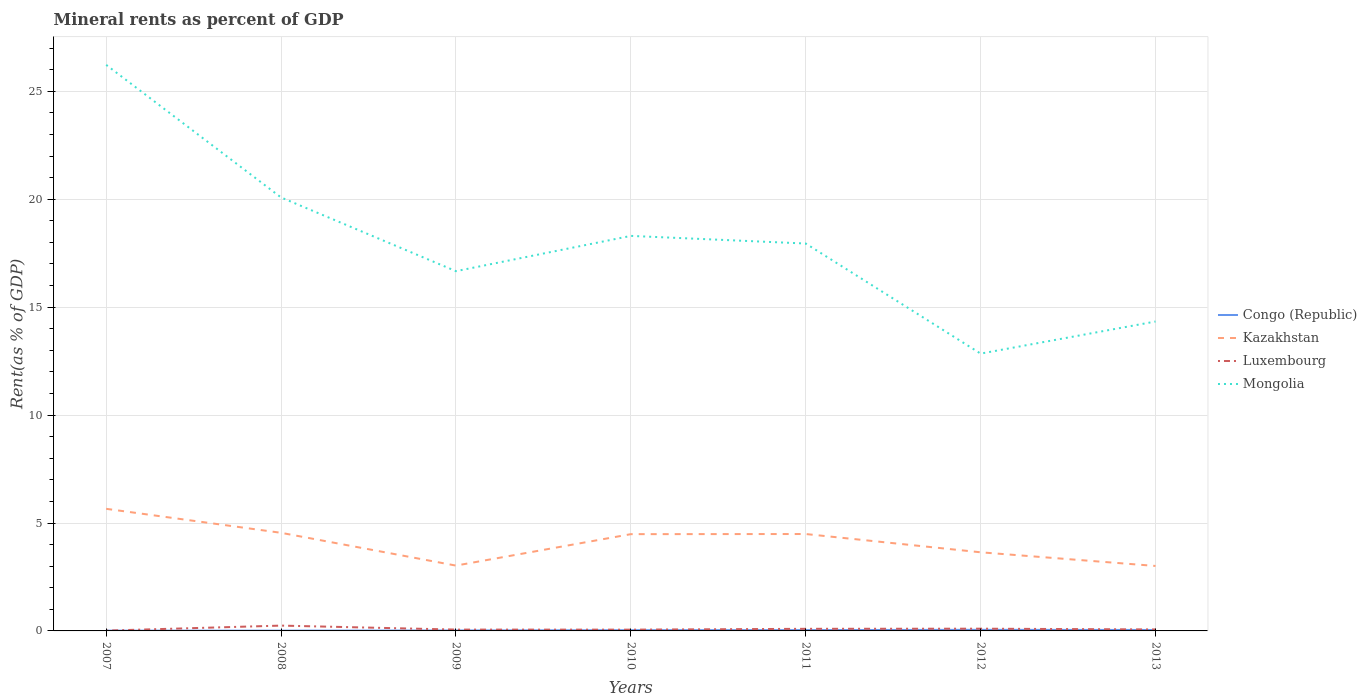How many different coloured lines are there?
Your answer should be very brief. 4. Does the line corresponding to Congo (Republic) intersect with the line corresponding to Kazakhstan?
Your response must be concise. No. Is the number of lines equal to the number of legend labels?
Offer a terse response. Yes. Across all years, what is the maximum mineral rent in Luxembourg?
Offer a very short reply. 0.01. In which year was the mineral rent in Luxembourg maximum?
Your response must be concise. 2007. What is the total mineral rent in Mongolia in the graph?
Your answer should be compact. 5.75. What is the difference between the highest and the second highest mineral rent in Congo (Republic)?
Provide a short and direct response. 0.04. Is the mineral rent in Luxembourg strictly greater than the mineral rent in Mongolia over the years?
Ensure brevity in your answer.  Yes. How many years are there in the graph?
Ensure brevity in your answer.  7. Does the graph contain any zero values?
Ensure brevity in your answer.  No. Where does the legend appear in the graph?
Keep it short and to the point. Center right. What is the title of the graph?
Make the answer very short. Mineral rents as percent of GDP. Does "New Zealand" appear as one of the legend labels in the graph?
Offer a very short reply. No. What is the label or title of the X-axis?
Offer a very short reply. Years. What is the label or title of the Y-axis?
Ensure brevity in your answer.  Rent(as % of GDP). What is the Rent(as % of GDP) in Congo (Republic) in 2007?
Your response must be concise. 0.01. What is the Rent(as % of GDP) in Kazakhstan in 2007?
Provide a short and direct response. 5.66. What is the Rent(as % of GDP) of Luxembourg in 2007?
Give a very brief answer. 0.01. What is the Rent(as % of GDP) of Mongolia in 2007?
Provide a short and direct response. 26.23. What is the Rent(as % of GDP) of Congo (Republic) in 2008?
Make the answer very short. 0.01. What is the Rent(as % of GDP) in Kazakhstan in 2008?
Your answer should be compact. 4.55. What is the Rent(as % of GDP) of Luxembourg in 2008?
Give a very brief answer. 0.25. What is the Rent(as % of GDP) of Mongolia in 2008?
Offer a very short reply. 20.08. What is the Rent(as % of GDP) in Congo (Republic) in 2009?
Make the answer very short. 0.02. What is the Rent(as % of GDP) in Kazakhstan in 2009?
Give a very brief answer. 3.03. What is the Rent(as % of GDP) of Luxembourg in 2009?
Your answer should be compact. 0.06. What is the Rent(as % of GDP) in Mongolia in 2009?
Your response must be concise. 16.67. What is the Rent(as % of GDP) in Congo (Republic) in 2010?
Offer a terse response. 0.03. What is the Rent(as % of GDP) of Kazakhstan in 2010?
Provide a succinct answer. 4.48. What is the Rent(as % of GDP) in Luxembourg in 2010?
Keep it short and to the point. 0.06. What is the Rent(as % of GDP) in Mongolia in 2010?
Make the answer very short. 18.3. What is the Rent(as % of GDP) in Congo (Republic) in 2011?
Ensure brevity in your answer.  0.04. What is the Rent(as % of GDP) in Kazakhstan in 2011?
Offer a very short reply. 4.49. What is the Rent(as % of GDP) of Luxembourg in 2011?
Your answer should be compact. 0.1. What is the Rent(as % of GDP) in Mongolia in 2011?
Your answer should be compact. 17.95. What is the Rent(as % of GDP) in Congo (Republic) in 2012?
Provide a short and direct response. 0.05. What is the Rent(as % of GDP) in Kazakhstan in 2012?
Offer a terse response. 3.64. What is the Rent(as % of GDP) in Luxembourg in 2012?
Provide a short and direct response. 0.1. What is the Rent(as % of GDP) in Mongolia in 2012?
Give a very brief answer. 12.85. What is the Rent(as % of GDP) of Congo (Republic) in 2013?
Make the answer very short. 0.04. What is the Rent(as % of GDP) of Kazakhstan in 2013?
Keep it short and to the point. 3.01. What is the Rent(as % of GDP) of Luxembourg in 2013?
Offer a very short reply. 0.07. What is the Rent(as % of GDP) in Mongolia in 2013?
Make the answer very short. 14.34. Across all years, what is the maximum Rent(as % of GDP) in Congo (Republic)?
Ensure brevity in your answer.  0.05. Across all years, what is the maximum Rent(as % of GDP) of Kazakhstan?
Your answer should be very brief. 5.66. Across all years, what is the maximum Rent(as % of GDP) in Luxembourg?
Keep it short and to the point. 0.25. Across all years, what is the maximum Rent(as % of GDP) of Mongolia?
Your answer should be compact. 26.23. Across all years, what is the minimum Rent(as % of GDP) of Congo (Republic)?
Your response must be concise. 0.01. Across all years, what is the minimum Rent(as % of GDP) in Kazakhstan?
Make the answer very short. 3.01. Across all years, what is the minimum Rent(as % of GDP) of Luxembourg?
Provide a short and direct response. 0.01. Across all years, what is the minimum Rent(as % of GDP) of Mongolia?
Provide a succinct answer. 12.85. What is the total Rent(as % of GDP) of Congo (Republic) in the graph?
Give a very brief answer. 0.21. What is the total Rent(as % of GDP) of Kazakhstan in the graph?
Give a very brief answer. 28.85. What is the total Rent(as % of GDP) in Luxembourg in the graph?
Your response must be concise. 0.65. What is the total Rent(as % of GDP) in Mongolia in the graph?
Provide a succinct answer. 126.41. What is the difference between the Rent(as % of GDP) in Congo (Republic) in 2007 and that in 2008?
Give a very brief answer. -0. What is the difference between the Rent(as % of GDP) in Kazakhstan in 2007 and that in 2008?
Make the answer very short. 1.11. What is the difference between the Rent(as % of GDP) in Luxembourg in 2007 and that in 2008?
Keep it short and to the point. -0.23. What is the difference between the Rent(as % of GDP) of Mongolia in 2007 and that in 2008?
Your answer should be very brief. 6.14. What is the difference between the Rent(as % of GDP) of Congo (Republic) in 2007 and that in 2009?
Offer a very short reply. -0.01. What is the difference between the Rent(as % of GDP) in Kazakhstan in 2007 and that in 2009?
Keep it short and to the point. 2.63. What is the difference between the Rent(as % of GDP) in Luxembourg in 2007 and that in 2009?
Your answer should be compact. -0.05. What is the difference between the Rent(as % of GDP) in Mongolia in 2007 and that in 2009?
Provide a short and direct response. 9.56. What is the difference between the Rent(as % of GDP) in Congo (Republic) in 2007 and that in 2010?
Offer a terse response. -0.02. What is the difference between the Rent(as % of GDP) in Kazakhstan in 2007 and that in 2010?
Your response must be concise. 1.17. What is the difference between the Rent(as % of GDP) of Luxembourg in 2007 and that in 2010?
Your answer should be compact. -0.04. What is the difference between the Rent(as % of GDP) in Mongolia in 2007 and that in 2010?
Your answer should be compact. 7.92. What is the difference between the Rent(as % of GDP) in Congo (Republic) in 2007 and that in 2011?
Ensure brevity in your answer.  -0.03. What is the difference between the Rent(as % of GDP) of Kazakhstan in 2007 and that in 2011?
Provide a succinct answer. 1.17. What is the difference between the Rent(as % of GDP) in Luxembourg in 2007 and that in 2011?
Offer a very short reply. -0.08. What is the difference between the Rent(as % of GDP) in Mongolia in 2007 and that in 2011?
Keep it short and to the point. 8.28. What is the difference between the Rent(as % of GDP) of Congo (Republic) in 2007 and that in 2012?
Your answer should be very brief. -0.04. What is the difference between the Rent(as % of GDP) in Kazakhstan in 2007 and that in 2012?
Offer a terse response. 2.01. What is the difference between the Rent(as % of GDP) of Luxembourg in 2007 and that in 2012?
Your answer should be compact. -0.09. What is the difference between the Rent(as % of GDP) in Mongolia in 2007 and that in 2012?
Offer a terse response. 13.38. What is the difference between the Rent(as % of GDP) in Congo (Republic) in 2007 and that in 2013?
Provide a succinct answer. -0.03. What is the difference between the Rent(as % of GDP) of Kazakhstan in 2007 and that in 2013?
Provide a short and direct response. 2.65. What is the difference between the Rent(as % of GDP) of Luxembourg in 2007 and that in 2013?
Make the answer very short. -0.05. What is the difference between the Rent(as % of GDP) in Mongolia in 2007 and that in 2013?
Provide a succinct answer. 11.89. What is the difference between the Rent(as % of GDP) of Congo (Republic) in 2008 and that in 2009?
Ensure brevity in your answer.  -0.01. What is the difference between the Rent(as % of GDP) of Kazakhstan in 2008 and that in 2009?
Your answer should be very brief. 1.52. What is the difference between the Rent(as % of GDP) of Luxembourg in 2008 and that in 2009?
Give a very brief answer. 0.18. What is the difference between the Rent(as % of GDP) of Mongolia in 2008 and that in 2009?
Make the answer very short. 3.42. What is the difference between the Rent(as % of GDP) of Congo (Republic) in 2008 and that in 2010?
Your answer should be compact. -0.02. What is the difference between the Rent(as % of GDP) of Kazakhstan in 2008 and that in 2010?
Keep it short and to the point. 0.06. What is the difference between the Rent(as % of GDP) of Luxembourg in 2008 and that in 2010?
Keep it short and to the point. 0.19. What is the difference between the Rent(as % of GDP) in Mongolia in 2008 and that in 2010?
Ensure brevity in your answer.  1.78. What is the difference between the Rent(as % of GDP) of Congo (Republic) in 2008 and that in 2011?
Ensure brevity in your answer.  -0.03. What is the difference between the Rent(as % of GDP) of Kazakhstan in 2008 and that in 2011?
Your answer should be compact. 0.06. What is the difference between the Rent(as % of GDP) in Luxembourg in 2008 and that in 2011?
Keep it short and to the point. 0.15. What is the difference between the Rent(as % of GDP) of Mongolia in 2008 and that in 2011?
Ensure brevity in your answer.  2.13. What is the difference between the Rent(as % of GDP) of Congo (Republic) in 2008 and that in 2012?
Your response must be concise. -0.04. What is the difference between the Rent(as % of GDP) in Kazakhstan in 2008 and that in 2012?
Ensure brevity in your answer.  0.9. What is the difference between the Rent(as % of GDP) of Luxembourg in 2008 and that in 2012?
Make the answer very short. 0.14. What is the difference between the Rent(as % of GDP) of Mongolia in 2008 and that in 2012?
Provide a short and direct response. 7.23. What is the difference between the Rent(as % of GDP) of Congo (Republic) in 2008 and that in 2013?
Offer a very short reply. -0.03. What is the difference between the Rent(as % of GDP) in Kazakhstan in 2008 and that in 2013?
Provide a succinct answer. 1.54. What is the difference between the Rent(as % of GDP) in Luxembourg in 2008 and that in 2013?
Give a very brief answer. 0.18. What is the difference between the Rent(as % of GDP) in Mongolia in 2008 and that in 2013?
Offer a terse response. 5.75. What is the difference between the Rent(as % of GDP) of Congo (Republic) in 2009 and that in 2010?
Your answer should be compact. -0.01. What is the difference between the Rent(as % of GDP) in Kazakhstan in 2009 and that in 2010?
Your response must be concise. -1.46. What is the difference between the Rent(as % of GDP) of Luxembourg in 2009 and that in 2010?
Ensure brevity in your answer.  0. What is the difference between the Rent(as % of GDP) of Mongolia in 2009 and that in 2010?
Make the answer very short. -1.63. What is the difference between the Rent(as % of GDP) in Congo (Republic) in 2009 and that in 2011?
Provide a succinct answer. -0.02. What is the difference between the Rent(as % of GDP) in Kazakhstan in 2009 and that in 2011?
Give a very brief answer. -1.46. What is the difference between the Rent(as % of GDP) of Luxembourg in 2009 and that in 2011?
Offer a terse response. -0.04. What is the difference between the Rent(as % of GDP) of Mongolia in 2009 and that in 2011?
Provide a short and direct response. -1.28. What is the difference between the Rent(as % of GDP) of Congo (Republic) in 2009 and that in 2012?
Keep it short and to the point. -0.03. What is the difference between the Rent(as % of GDP) in Kazakhstan in 2009 and that in 2012?
Provide a succinct answer. -0.62. What is the difference between the Rent(as % of GDP) of Luxembourg in 2009 and that in 2012?
Keep it short and to the point. -0.04. What is the difference between the Rent(as % of GDP) of Mongolia in 2009 and that in 2012?
Your answer should be compact. 3.82. What is the difference between the Rent(as % of GDP) of Congo (Republic) in 2009 and that in 2013?
Your answer should be compact. -0.02. What is the difference between the Rent(as % of GDP) of Kazakhstan in 2009 and that in 2013?
Ensure brevity in your answer.  0.02. What is the difference between the Rent(as % of GDP) in Luxembourg in 2009 and that in 2013?
Offer a very short reply. -0.01. What is the difference between the Rent(as % of GDP) of Mongolia in 2009 and that in 2013?
Make the answer very short. 2.33. What is the difference between the Rent(as % of GDP) in Congo (Republic) in 2010 and that in 2011?
Make the answer very short. -0. What is the difference between the Rent(as % of GDP) of Kazakhstan in 2010 and that in 2011?
Your response must be concise. -0.01. What is the difference between the Rent(as % of GDP) in Luxembourg in 2010 and that in 2011?
Your answer should be compact. -0.04. What is the difference between the Rent(as % of GDP) in Mongolia in 2010 and that in 2011?
Keep it short and to the point. 0.35. What is the difference between the Rent(as % of GDP) of Congo (Republic) in 2010 and that in 2012?
Make the answer very short. -0.02. What is the difference between the Rent(as % of GDP) of Kazakhstan in 2010 and that in 2012?
Provide a short and direct response. 0.84. What is the difference between the Rent(as % of GDP) in Luxembourg in 2010 and that in 2012?
Provide a succinct answer. -0.04. What is the difference between the Rent(as % of GDP) of Mongolia in 2010 and that in 2012?
Provide a succinct answer. 5.45. What is the difference between the Rent(as % of GDP) of Congo (Republic) in 2010 and that in 2013?
Provide a succinct answer. -0.01. What is the difference between the Rent(as % of GDP) in Kazakhstan in 2010 and that in 2013?
Your response must be concise. 1.47. What is the difference between the Rent(as % of GDP) of Luxembourg in 2010 and that in 2013?
Offer a very short reply. -0.01. What is the difference between the Rent(as % of GDP) in Mongolia in 2010 and that in 2013?
Ensure brevity in your answer.  3.97. What is the difference between the Rent(as % of GDP) of Congo (Republic) in 2011 and that in 2012?
Keep it short and to the point. -0.01. What is the difference between the Rent(as % of GDP) of Kazakhstan in 2011 and that in 2012?
Ensure brevity in your answer.  0.85. What is the difference between the Rent(as % of GDP) of Luxembourg in 2011 and that in 2012?
Your answer should be compact. -0.01. What is the difference between the Rent(as % of GDP) in Mongolia in 2011 and that in 2012?
Ensure brevity in your answer.  5.1. What is the difference between the Rent(as % of GDP) in Congo (Republic) in 2011 and that in 2013?
Your answer should be compact. -0.01. What is the difference between the Rent(as % of GDP) in Kazakhstan in 2011 and that in 2013?
Offer a very short reply. 1.48. What is the difference between the Rent(as % of GDP) of Luxembourg in 2011 and that in 2013?
Give a very brief answer. 0.03. What is the difference between the Rent(as % of GDP) in Mongolia in 2011 and that in 2013?
Provide a succinct answer. 3.61. What is the difference between the Rent(as % of GDP) in Congo (Republic) in 2012 and that in 2013?
Offer a very short reply. 0.01. What is the difference between the Rent(as % of GDP) in Kazakhstan in 2012 and that in 2013?
Your response must be concise. 0.63. What is the difference between the Rent(as % of GDP) in Luxembourg in 2012 and that in 2013?
Your answer should be very brief. 0.04. What is the difference between the Rent(as % of GDP) in Mongolia in 2012 and that in 2013?
Your answer should be very brief. -1.49. What is the difference between the Rent(as % of GDP) of Congo (Republic) in 2007 and the Rent(as % of GDP) of Kazakhstan in 2008?
Your answer should be compact. -4.53. What is the difference between the Rent(as % of GDP) in Congo (Republic) in 2007 and the Rent(as % of GDP) in Luxembourg in 2008?
Offer a very short reply. -0.23. What is the difference between the Rent(as % of GDP) of Congo (Republic) in 2007 and the Rent(as % of GDP) of Mongolia in 2008?
Your response must be concise. -20.07. What is the difference between the Rent(as % of GDP) in Kazakhstan in 2007 and the Rent(as % of GDP) in Luxembourg in 2008?
Keep it short and to the point. 5.41. What is the difference between the Rent(as % of GDP) of Kazakhstan in 2007 and the Rent(as % of GDP) of Mongolia in 2008?
Offer a very short reply. -14.43. What is the difference between the Rent(as % of GDP) in Luxembourg in 2007 and the Rent(as % of GDP) in Mongolia in 2008?
Your response must be concise. -20.07. What is the difference between the Rent(as % of GDP) in Congo (Republic) in 2007 and the Rent(as % of GDP) in Kazakhstan in 2009?
Ensure brevity in your answer.  -3.01. What is the difference between the Rent(as % of GDP) in Congo (Republic) in 2007 and the Rent(as % of GDP) in Luxembourg in 2009?
Your response must be concise. -0.05. What is the difference between the Rent(as % of GDP) of Congo (Republic) in 2007 and the Rent(as % of GDP) of Mongolia in 2009?
Provide a short and direct response. -16.65. What is the difference between the Rent(as % of GDP) in Kazakhstan in 2007 and the Rent(as % of GDP) in Luxembourg in 2009?
Offer a terse response. 5.6. What is the difference between the Rent(as % of GDP) in Kazakhstan in 2007 and the Rent(as % of GDP) in Mongolia in 2009?
Give a very brief answer. -11.01. What is the difference between the Rent(as % of GDP) in Luxembourg in 2007 and the Rent(as % of GDP) in Mongolia in 2009?
Offer a terse response. -16.65. What is the difference between the Rent(as % of GDP) in Congo (Republic) in 2007 and the Rent(as % of GDP) in Kazakhstan in 2010?
Provide a succinct answer. -4.47. What is the difference between the Rent(as % of GDP) in Congo (Republic) in 2007 and the Rent(as % of GDP) in Luxembourg in 2010?
Provide a succinct answer. -0.05. What is the difference between the Rent(as % of GDP) in Congo (Republic) in 2007 and the Rent(as % of GDP) in Mongolia in 2010?
Your response must be concise. -18.29. What is the difference between the Rent(as % of GDP) of Kazakhstan in 2007 and the Rent(as % of GDP) of Luxembourg in 2010?
Ensure brevity in your answer.  5.6. What is the difference between the Rent(as % of GDP) in Kazakhstan in 2007 and the Rent(as % of GDP) in Mongolia in 2010?
Offer a very short reply. -12.64. What is the difference between the Rent(as % of GDP) of Luxembourg in 2007 and the Rent(as % of GDP) of Mongolia in 2010?
Ensure brevity in your answer.  -18.29. What is the difference between the Rent(as % of GDP) of Congo (Republic) in 2007 and the Rent(as % of GDP) of Kazakhstan in 2011?
Offer a very short reply. -4.48. What is the difference between the Rent(as % of GDP) in Congo (Republic) in 2007 and the Rent(as % of GDP) in Luxembourg in 2011?
Your response must be concise. -0.08. What is the difference between the Rent(as % of GDP) in Congo (Republic) in 2007 and the Rent(as % of GDP) in Mongolia in 2011?
Offer a very short reply. -17.93. What is the difference between the Rent(as % of GDP) in Kazakhstan in 2007 and the Rent(as % of GDP) in Luxembourg in 2011?
Your response must be concise. 5.56. What is the difference between the Rent(as % of GDP) of Kazakhstan in 2007 and the Rent(as % of GDP) of Mongolia in 2011?
Keep it short and to the point. -12.29. What is the difference between the Rent(as % of GDP) in Luxembourg in 2007 and the Rent(as % of GDP) in Mongolia in 2011?
Provide a succinct answer. -17.93. What is the difference between the Rent(as % of GDP) in Congo (Republic) in 2007 and the Rent(as % of GDP) in Kazakhstan in 2012?
Keep it short and to the point. -3.63. What is the difference between the Rent(as % of GDP) of Congo (Republic) in 2007 and the Rent(as % of GDP) of Luxembourg in 2012?
Ensure brevity in your answer.  -0.09. What is the difference between the Rent(as % of GDP) in Congo (Republic) in 2007 and the Rent(as % of GDP) in Mongolia in 2012?
Your answer should be compact. -12.84. What is the difference between the Rent(as % of GDP) in Kazakhstan in 2007 and the Rent(as % of GDP) in Luxembourg in 2012?
Offer a terse response. 5.55. What is the difference between the Rent(as % of GDP) of Kazakhstan in 2007 and the Rent(as % of GDP) of Mongolia in 2012?
Your response must be concise. -7.19. What is the difference between the Rent(as % of GDP) in Luxembourg in 2007 and the Rent(as % of GDP) in Mongolia in 2012?
Your answer should be very brief. -12.83. What is the difference between the Rent(as % of GDP) of Congo (Republic) in 2007 and the Rent(as % of GDP) of Kazakhstan in 2013?
Provide a succinct answer. -3. What is the difference between the Rent(as % of GDP) in Congo (Republic) in 2007 and the Rent(as % of GDP) in Luxembourg in 2013?
Your answer should be very brief. -0.06. What is the difference between the Rent(as % of GDP) in Congo (Republic) in 2007 and the Rent(as % of GDP) in Mongolia in 2013?
Your response must be concise. -14.32. What is the difference between the Rent(as % of GDP) of Kazakhstan in 2007 and the Rent(as % of GDP) of Luxembourg in 2013?
Your answer should be compact. 5.59. What is the difference between the Rent(as % of GDP) in Kazakhstan in 2007 and the Rent(as % of GDP) in Mongolia in 2013?
Your answer should be compact. -8.68. What is the difference between the Rent(as % of GDP) in Luxembourg in 2007 and the Rent(as % of GDP) in Mongolia in 2013?
Offer a very short reply. -14.32. What is the difference between the Rent(as % of GDP) of Congo (Republic) in 2008 and the Rent(as % of GDP) of Kazakhstan in 2009?
Ensure brevity in your answer.  -3.01. What is the difference between the Rent(as % of GDP) of Congo (Republic) in 2008 and the Rent(as % of GDP) of Luxembourg in 2009?
Keep it short and to the point. -0.05. What is the difference between the Rent(as % of GDP) of Congo (Republic) in 2008 and the Rent(as % of GDP) of Mongolia in 2009?
Your answer should be very brief. -16.65. What is the difference between the Rent(as % of GDP) in Kazakhstan in 2008 and the Rent(as % of GDP) in Luxembourg in 2009?
Give a very brief answer. 4.48. What is the difference between the Rent(as % of GDP) of Kazakhstan in 2008 and the Rent(as % of GDP) of Mongolia in 2009?
Offer a terse response. -12.12. What is the difference between the Rent(as % of GDP) in Luxembourg in 2008 and the Rent(as % of GDP) in Mongolia in 2009?
Your answer should be compact. -16.42. What is the difference between the Rent(as % of GDP) in Congo (Republic) in 2008 and the Rent(as % of GDP) in Kazakhstan in 2010?
Offer a terse response. -4.47. What is the difference between the Rent(as % of GDP) in Congo (Republic) in 2008 and the Rent(as % of GDP) in Luxembourg in 2010?
Keep it short and to the point. -0.05. What is the difference between the Rent(as % of GDP) in Congo (Republic) in 2008 and the Rent(as % of GDP) in Mongolia in 2010?
Ensure brevity in your answer.  -18.29. What is the difference between the Rent(as % of GDP) of Kazakhstan in 2008 and the Rent(as % of GDP) of Luxembourg in 2010?
Make the answer very short. 4.49. What is the difference between the Rent(as % of GDP) of Kazakhstan in 2008 and the Rent(as % of GDP) of Mongolia in 2010?
Make the answer very short. -13.76. What is the difference between the Rent(as % of GDP) in Luxembourg in 2008 and the Rent(as % of GDP) in Mongolia in 2010?
Make the answer very short. -18.06. What is the difference between the Rent(as % of GDP) in Congo (Republic) in 2008 and the Rent(as % of GDP) in Kazakhstan in 2011?
Your response must be concise. -4.48. What is the difference between the Rent(as % of GDP) of Congo (Republic) in 2008 and the Rent(as % of GDP) of Luxembourg in 2011?
Give a very brief answer. -0.08. What is the difference between the Rent(as % of GDP) in Congo (Republic) in 2008 and the Rent(as % of GDP) in Mongolia in 2011?
Offer a terse response. -17.93. What is the difference between the Rent(as % of GDP) in Kazakhstan in 2008 and the Rent(as % of GDP) in Luxembourg in 2011?
Your answer should be compact. 4.45. What is the difference between the Rent(as % of GDP) in Kazakhstan in 2008 and the Rent(as % of GDP) in Mongolia in 2011?
Provide a succinct answer. -13.4. What is the difference between the Rent(as % of GDP) of Luxembourg in 2008 and the Rent(as % of GDP) of Mongolia in 2011?
Your answer should be compact. -17.7. What is the difference between the Rent(as % of GDP) of Congo (Republic) in 2008 and the Rent(as % of GDP) of Kazakhstan in 2012?
Make the answer very short. -3.63. What is the difference between the Rent(as % of GDP) in Congo (Republic) in 2008 and the Rent(as % of GDP) in Luxembourg in 2012?
Your answer should be very brief. -0.09. What is the difference between the Rent(as % of GDP) in Congo (Republic) in 2008 and the Rent(as % of GDP) in Mongolia in 2012?
Provide a succinct answer. -12.84. What is the difference between the Rent(as % of GDP) of Kazakhstan in 2008 and the Rent(as % of GDP) of Luxembourg in 2012?
Provide a short and direct response. 4.44. What is the difference between the Rent(as % of GDP) of Kazakhstan in 2008 and the Rent(as % of GDP) of Mongolia in 2012?
Your response must be concise. -8.3. What is the difference between the Rent(as % of GDP) of Luxembourg in 2008 and the Rent(as % of GDP) of Mongolia in 2012?
Give a very brief answer. -12.6. What is the difference between the Rent(as % of GDP) of Congo (Republic) in 2008 and the Rent(as % of GDP) of Kazakhstan in 2013?
Give a very brief answer. -3. What is the difference between the Rent(as % of GDP) of Congo (Republic) in 2008 and the Rent(as % of GDP) of Luxembourg in 2013?
Give a very brief answer. -0.05. What is the difference between the Rent(as % of GDP) of Congo (Republic) in 2008 and the Rent(as % of GDP) of Mongolia in 2013?
Your answer should be compact. -14.32. What is the difference between the Rent(as % of GDP) of Kazakhstan in 2008 and the Rent(as % of GDP) of Luxembourg in 2013?
Provide a short and direct response. 4.48. What is the difference between the Rent(as % of GDP) in Kazakhstan in 2008 and the Rent(as % of GDP) in Mongolia in 2013?
Your response must be concise. -9.79. What is the difference between the Rent(as % of GDP) in Luxembourg in 2008 and the Rent(as % of GDP) in Mongolia in 2013?
Your answer should be compact. -14.09. What is the difference between the Rent(as % of GDP) of Congo (Republic) in 2009 and the Rent(as % of GDP) of Kazakhstan in 2010?
Your answer should be very brief. -4.46. What is the difference between the Rent(as % of GDP) in Congo (Republic) in 2009 and the Rent(as % of GDP) in Luxembourg in 2010?
Offer a very short reply. -0.04. What is the difference between the Rent(as % of GDP) in Congo (Republic) in 2009 and the Rent(as % of GDP) in Mongolia in 2010?
Offer a very short reply. -18.28. What is the difference between the Rent(as % of GDP) in Kazakhstan in 2009 and the Rent(as % of GDP) in Luxembourg in 2010?
Your answer should be compact. 2.97. What is the difference between the Rent(as % of GDP) in Kazakhstan in 2009 and the Rent(as % of GDP) in Mongolia in 2010?
Your response must be concise. -15.27. What is the difference between the Rent(as % of GDP) of Luxembourg in 2009 and the Rent(as % of GDP) of Mongolia in 2010?
Ensure brevity in your answer.  -18.24. What is the difference between the Rent(as % of GDP) in Congo (Republic) in 2009 and the Rent(as % of GDP) in Kazakhstan in 2011?
Offer a very short reply. -4.47. What is the difference between the Rent(as % of GDP) in Congo (Republic) in 2009 and the Rent(as % of GDP) in Luxembourg in 2011?
Offer a very short reply. -0.08. What is the difference between the Rent(as % of GDP) in Congo (Republic) in 2009 and the Rent(as % of GDP) in Mongolia in 2011?
Your answer should be compact. -17.93. What is the difference between the Rent(as % of GDP) of Kazakhstan in 2009 and the Rent(as % of GDP) of Luxembourg in 2011?
Offer a very short reply. 2.93. What is the difference between the Rent(as % of GDP) in Kazakhstan in 2009 and the Rent(as % of GDP) in Mongolia in 2011?
Your answer should be compact. -14.92. What is the difference between the Rent(as % of GDP) of Luxembourg in 2009 and the Rent(as % of GDP) of Mongolia in 2011?
Keep it short and to the point. -17.89. What is the difference between the Rent(as % of GDP) in Congo (Republic) in 2009 and the Rent(as % of GDP) in Kazakhstan in 2012?
Offer a terse response. -3.62. What is the difference between the Rent(as % of GDP) of Congo (Republic) in 2009 and the Rent(as % of GDP) of Luxembourg in 2012?
Your response must be concise. -0.08. What is the difference between the Rent(as % of GDP) in Congo (Republic) in 2009 and the Rent(as % of GDP) in Mongolia in 2012?
Your response must be concise. -12.83. What is the difference between the Rent(as % of GDP) in Kazakhstan in 2009 and the Rent(as % of GDP) in Luxembourg in 2012?
Make the answer very short. 2.92. What is the difference between the Rent(as % of GDP) of Kazakhstan in 2009 and the Rent(as % of GDP) of Mongolia in 2012?
Keep it short and to the point. -9.82. What is the difference between the Rent(as % of GDP) in Luxembourg in 2009 and the Rent(as % of GDP) in Mongolia in 2012?
Provide a succinct answer. -12.79. What is the difference between the Rent(as % of GDP) in Congo (Republic) in 2009 and the Rent(as % of GDP) in Kazakhstan in 2013?
Provide a short and direct response. -2.99. What is the difference between the Rent(as % of GDP) in Congo (Republic) in 2009 and the Rent(as % of GDP) in Luxembourg in 2013?
Provide a succinct answer. -0.05. What is the difference between the Rent(as % of GDP) of Congo (Republic) in 2009 and the Rent(as % of GDP) of Mongolia in 2013?
Offer a terse response. -14.31. What is the difference between the Rent(as % of GDP) in Kazakhstan in 2009 and the Rent(as % of GDP) in Luxembourg in 2013?
Provide a short and direct response. 2.96. What is the difference between the Rent(as % of GDP) in Kazakhstan in 2009 and the Rent(as % of GDP) in Mongolia in 2013?
Your answer should be compact. -11.31. What is the difference between the Rent(as % of GDP) in Luxembourg in 2009 and the Rent(as % of GDP) in Mongolia in 2013?
Your answer should be very brief. -14.27. What is the difference between the Rent(as % of GDP) in Congo (Republic) in 2010 and the Rent(as % of GDP) in Kazakhstan in 2011?
Your answer should be very brief. -4.46. What is the difference between the Rent(as % of GDP) in Congo (Republic) in 2010 and the Rent(as % of GDP) in Luxembourg in 2011?
Your answer should be very brief. -0.06. What is the difference between the Rent(as % of GDP) of Congo (Republic) in 2010 and the Rent(as % of GDP) of Mongolia in 2011?
Make the answer very short. -17.91. What is the difference between the Rent(as % of GDP) of Kazakhstan in 2010 and the Rent(as % of GDP) of Luxembourg in 2011?
Your response must be concise. 4.39. What is the difference between the Rent(as % of GDP) in Kazakhstan in 2010 and the Rent(as % of GDP) in Mongolia in 2011?
Your answer should be very brief. -13.46. What is the difference between the Rent(as % of GDP) in Luxembourg in 2010 and the Rent(as % of GDP) in Mongolia in 2011?
Your answer should be very brief. -17.89. What is the difference between the Rent(as % of GDP) in Congo (Republic) in 2010 and the Rent(as % of GDP) in Kazakhstan in 2012?
Your answer should be compact. -3.61. What is the difference between the Rent(as % of GDP) in Congo (Republic) in 2010 and the Rent(as % of GDP) in Luxembourg in 2012?
Give a very brief answer. -0.07. What is the difference between the Rent(as % of GDP) in Congo (Republic) in 2010 and the Rent(as % of GDP) in Mongolia in 2012?
Your answer should be very brief. -12.81. What is the difference between the Rent(as % of GDP) of Kazakhstan in 2010 and the Rent(as % of GDP) of Luxembourg in 2012?
Make the answer very short. 4.38. What is the difference between the Rent(as % of GDP) of Kazakhstan in 2010 and the Rent(as % of GDP) of Mongolia in 2012?
Provide a succinct answer. -8.36. What is the difference between the Rent(as % of GDP) of Luxembourg in 2010 and the Rent(as % of GDP) of Mongolia in 2012?
Keep it short and to the point. -12.79. What is the difference between the Rent(as % of GDP) in Congo (Republic) in 2010 and the Rent(as % of GDP) in Kazakhstan in 2013?
Keep it short and to the point. -2.98. What is the difference between the Rent(as % of GDP) of Congo (Republic) in 2010 and the Rent(as % of GDP) of Luxembourg in 2013?
Make the answer very short. -0.03. What is the difference between the Rent(as % of GDP) in Congo (Republic) in 2010 and the Rent(as % of GDP) in Mongolia in 2013?
Make the answer very short. -14.3. What is the difference between the Rent(as % of GDP) of Kazakhstan in 2010 and the Rent(as % of GDP) of Luxembourg in 2013?
Ensure brevity in your answer.  4.42. What is the difference between the Rent(as % of GDP) of Kazakhstan in 2010 and the Rent(as % of GDP) of Mongolia in 2013?
Your response must be concise. -9.85. What is the difference between the Rent(as % of GDP) of Luxembourg in 2010 and the Rent(as % of GDP) of Mongolia in 2013?
Your answer should be compact. -14.28. What is the difference between the Rent(as % of GDP) in Congo (Republic) in 2011 and the Rent(as % of GDP) in Kazakhstan in 2012?
Give a very brief answer. -3.6. What is the difference between the Rent(as % of GDP) in Congo (Republic) in 2011 and the Rent(as % of GDP) in Luxembourg in 2012?
Give a very brief answer. -0.07. What is the difference between the Rent(as % of GDP) of Congo (Republic) in 2011 and the Rent(as % of GDP) of Mongolia in 2012?
Ensure brevity in your answer.  -12.81. What is the difference between the Rent(as % of GDP) of Kazakhstan in 2011 and the Rent(as % of GDP) of Luxembourg in 2012?
Keep it short and to the point. 4.39. What is the difference between the Rent(as % of GDP) in Kazakhstan in 2011 and the Rent(as % of GDP) in Mongolia in 2012?
Offer a terse response. -8.36. What is the difference between the Rent(as % of GDP) in Luxembourg in 2011 and the Rent(as % of GDP) in Mongolia in 2012?
Provide a succinct answer. -12.75. What is the difference between the Rent(as % of GDP) in Congo (Republic) in 2011 and the Rent(as % of GDP) in Kazakhstan in 2013?
Ensure brevity in your answer.  -2.97. What is the difference between the Rent(as % of GDP) in Congo (Republic) in 2011 and the Rent(as % of GDP) in Luxembourg in 2013?
Make the answer very short. -0.03. What is the difference between the Rent(as % of GDP) of Congo (Republic) in 2011 and the Rent(as % of GDP) of Mongolia in 2013?
Provide a succinct answer. -14.3. What is the difference between the Rent(as % of GDP) of Kazakhstan in 2011 and the Rent(as % of GDP) of Luxembourg in 2013?
Offer a very short reply. 4.42. What is the difference between the Rent(as % of GDP) in Kazakhstan in 2011 and the Rent(as % of GDP) in Mongolia in 2013?
Your answer should be compact. -9.85. What is the difference between the Rent(as % of GDP) of Luxembourg in 2011 and the Rent(as % of GDP) of Mongolia in 2013?
Provide a short and direct response. -14.24. What is the difference between the Rent(as % of GDP) of Congo (Republic) in 2012 and the Rent(as % of GDP) of Kazakhstan in 2013?
Your answer should be compact. -2.96. What is the difference between the Rent(as % of GDP) of Congo (Republic) in 2012 and the Rent(as % of GDP) of Luxembourg in 2013?
Give a very brief answer. -0.02. What is the difference between the Rent(as % of GDP) of Congo (Republic) in 2012 and the Rent(as % of GDP) of Mongolia in 2013?
Ensure brevity in your answer.  -14.28. What is the difference between the Rent(as % of GDP) of Kazakhstan in 2012 and the Rent(as % of GDP) of Luxembourg in 2013?
Provide a short and direct response. 3.58. What is the difference between the Rent(as % of GDP) in Kazakhstan in 2012 and the Rent(as % of GDP) in Mongolia in 2013?
Provide a succinct answer. -10.69. What is the difference between the Rent(as % of GDP) in Luxembourg in 2012 and the Rent(as % of GDP) in Mongolia in 2013?
Your answer should be compact. -14.23. What is the average Rent(as % of GDP) of Congo (Republic) per year?
Give a very brief answer. 0.03. What is the average Rent(as % of GDP) of Kazakhstan per year?
Your response must be concise. 4.12. What is the average Rent(as % of GDP) of Luxembourg per year?
Offer a terse response. 0.09. What is the average Rent(as % of GDP) of Mongolia per year?
Your answer should be very brief. 18.06. In the year 2007, what is the difference between the Rent(as % of GDP) of Congo (Republic) and Rent(as % of GDP) of Kazakhstan?
Offer a very short reply. -5.64. In the year 2007, what is the difference between the Rent(as % of GDP) of Congo (Republic) and Rent(as % of GDP) of Luxembourg?
Give a very brief answer. -0. In the year 2007, what is the difference between the Rent(as % of GDP) in Congo (Republic) and Rent(as % of GDP) in Mongolia?
Your response must be concise. -26.21. In the year 2007, what is the difference between the Rent(as % of GDP) of Kazakhstan and Rent(as % of GDP) of Luxembourg?
Your answer should be compact. 5.64. In the year 2007, what is the difference between the Rent(as % of GDP) of Kazakhstan and Rent(as % of GDP) of Mongolia?
Offer a terse response. -20.57. In the year 2007, what is the difference between the Rent(as % of GDP) in Luxembourg and Rent(as % of GDP) in Mongolia?
Make the answer very short. -26.21. In the year 2008, what is the difference between the Rent(as % of GDP) in Congo (Republic) and Rent(as % of GDP) in Kazakhstan?
Keep it short and to the point. -4.53. In the year 2008, what is the difference between the Rent(as % of GDP) of Congo (Republic) and Rent(as % of GDP) of Luxembourg?
Offer a terse response. -0.23. In the year 2008, what is the difference between the Rent(as % of GDP) of Congo (Republic) and Rent(as % of GDP) of Mongolia?
Ensure brevity in your answer.  -20.07. In the year 2008, what is the difference between the Rent(as % of GDP) of Kazakhstan and Rent(as % of GDP) of Luxembourg?
Ensure brevity in your answer.  4.3. In the year 2008, what is the difference between the Rent(as % of GDP) in Kazakhstan and Rent(as % of GDP) in Mongolia?
Your response must be concise. -15.54. In the year 2008, what is the difference between the Rent(as % of GDP) in Luxembourg and Rent(as % of GDP) in Mongolia?
Make the answer very short. -19.84. In the year 2009, what is the difference between the Rent(as % of GDP) of Congo (Republic) and Rent(as % of GDP) of Kazakhstan?
Keep it short and to the point. -3.01. In the year 2009, what is the difference between the Rent(as % of GDP) of Congo (Republic) and Rent(as % of GDP) of Luxembourg?
Your answer should be very brief. -0.04. In the year 2009, what is the difference between the Rent(as % of GDP) in Congo (Republic) and Rent(as % of GDP) in Mongolia?
Provide a succinct answer. -16.65. In the year 2009, what is the difference between the Rent(as % of GDP) of Kazakhstan and Rent(as % of GDP) of Luxembourg?
Provide a succinct answer. 2.96. In the year 2009, what is the difference between the Rent(as % of GDP) in Kazakhstan and Rent(as % of GDP) in Mongolia?
Keep it short and to the point. -13.64. In the year 2009, what is the difference between the Rent(as % of GDP) of Luxembourg and Rent(as % of GDP) of Mongolia?
Your answer should be very brief. -16.61. In the year 2010, what is the difference between the Rent(as % of GDP) of Congo (Republic) and Rent(as % of GDP) of Kazakhstan?
Offer a very short reply. -4.45. In the year 2010, what is the difference between the Rent(as % of GDP) in Congo (Republic) and Rent(as % of GDP) in Luxembourg?
Offer a very short reply. -0.02. In the year 2010, what is the difference between the Rent(as % of GDP) in Congo (Republic) and Rent(as % of GDP) in Mongolia?
Give a very brief answer. -18.27. In the year 2010, what is the difference between the Rent(as % of GDP) in Kazakhstan and Rent(as % of GDP) in Luxembourg?
Your response must be concise. 4.42. In the year 2010, what is the difference between the Rent(as % of GDP) in Kazakhstan and Rent(as % of GDP) in Mongolia?
Your answer should be compact. -13.82. In the year 2010, what is the difference between the Rent(as % of GDP) of Luxembourg and Rent(as % of GDP) of Mongolia?
Offer a very short reply. -18.24. In the year 2011, what is the difference between the Rent(as % of GDP) of Congo (Republic) and Rent(as % of GDP) of Kazakhstan?
Provide a succinct answer. -4.45. In the year 2011, what is the difference between the Rent(as % of GDP) in Congo (Republic) and Rent(as % of GDP) in Luxembourg?
Give a very brief answer. -0.06. In the year 2011, what is the difference between the Rent(as % of GDP) of Congo (Republic) and Rent(as % of GDP) of Mongolia?
Your answer should be very brief. -17.91. In the year 2011, what is the difference between the Rent(as % of GDP) in Kazakhstan and Rent(as % of GDP) in Luxembourg?
Give a very brief answer. 4.39. In the year 2011, what is the difference between the Rent(as % of GDP) of Kazakhstan and Rent(as % of GDP) of Mongolia?
Give a very brief answer. -13.46. In the year 2011, what is the difference between the Rent(as % of GDP) in Luxembourg and Rent(as % of GDP) in Mongolia?
Provide a succinct answer. -17.85. In the year 2012, what is the difference between the Rent(as % of GDP) in Congo (Republic) and Rent(as % of GDP) in Kazakhstan?
Provide a short and direct response. -3.59. In the year 2012, what is the difference between the Rent(as % of GDP) of Congo (Republic) and Rent(as % of GDP) of Luxembourg?
Your answer should be compact. -0.05. In the year 2012, what is the difference between the Rent(as % of GDP) in Congo (Republic) and Rent(as % of GDP) in Mongolia?
Keep it short and to the point. -12.8. In the year 2012, what is the difference between the Rent(as % of GDP) of Kazakhstan and Rent(as % of GDP) of Luxembourg?
Your answer should be very brief. 3.54. In the year 2012, what is the difference between the Rent(as % of GDP) in Kazakhstan and Rent(as % of GDP) in Mongolia?
Keep it short and to the point. -9.21. In the year 2012, what is the difference between the Rent(as % of GDP) in Luxembourg and Rent(as % of GDP) in Mongolia?
Your answer should be very brief. -12.74. In the year 2013, what is the difference between the Rent(as % of GDP) of Congo (Republic) and Rent(as % of GDP) of Kazakhstan?
Make the answer very short. -2.97. In the year 2013, what is the difference between the Rent(as % of GDP) of Congo (Republic) and Rent(as % of GDP) of Luxembourg?
Your answer should be compact. -0.02. In the year 2013, what is the difference between the Rent(as % of GDP) of Congo (Republic) and Rent(as % of GDP) of Mongolia?
Provide a succinct answer. -14.29. In the year 2013, what is the difference between the Rent(as % of GDP) in Kazakhstan and Rent(as % of GDP) in Luxembourg?
Provide a short and direct response. 2.94. In the year 2013, what is the difference between the Rent(as % of GDP) in Kazakhstan and Rent(as % of GDP) in Mongolia?
Offer a very short reply. -11.33. In the year 2013, what is the difference between the Rent(as % of GDP) in Luxembourg and Rent(as % of GDP) in Mongolia?
Offer a terse response. -14.27. What is the ratio of the Rent(as % of GDP) of Congo (Republic) in 2007 to that in 2008?
Offer a very short reply. 0.98. What is the ratio of the Rent(as % of GDP) in Kazakhstan in 2007 to that in 2008?
Your answer should be very brief. 1.24. What is the ratio of the Rent(as % of GDP) in Luxembourg in 2007 to that in 2008?
Your answer should be very brief. 0.06. What is the ratio of the Rent(as % of GDP) of Mongolia in 2007 to that in 2008?
Keep it short and to the point. 1.31. What is the ratio of the Rent(as % of GDP) in Congo (Republic) in 2007 to that in 2009?
Provide a succinct answer. 0.63. What is the ratio of the Rent(as % of GDP) in Kazakhstan in 2007 to that in 2009?
Make the answer very short. 1.87. What is the ratio of the Rent(as % of GDP) in Luxembourg in 2007 to that in 2009?
Give a very brief answer. 0.23. What is the ratio of the Rent(as % of GDP) in Mongolia in 2007 to that in 2009?
Keep it short and to the point. 1.57. What is the ratio of the Rent(as % of GDP) in Congo (Republic) in 2007 to that in 2010?
Your response must be concise. 0.38. What is the ratio of the Rent(as % of GDP) of Kazakhstan in 2007 to that in 2010?
Your response must be concise. 1.26. What is the ratio of the Rent(as % of GDP) in Luxembourg in 2007 to that in 2010?
Keep it short and to the point. 0.25. What is the ratio of the Rent(as % of GDP) in Mongolia in 2007 to that in 2010?
Give a very brief answer. 1.43. What is the ratio of the Rent(as % of GDP) of Congo (Republic) in 2007 to that in 2011?
Provide a succinct answer. 0.33. What is the ratio of the Rent(as % of GDP) of Kazakhstan in 2007 to that in 2011?
Keep it short and to the point. 1.26. What is the ratio of the Rent(as % of GDP) in Luxembourg in 2007 to that in 2011?
Provide a short and direct response. 0.15. What is the ratio of the Rent(as % of GDP) of Mongolia in 2007 to that in 2011?
Ensure brevity in your answer.  1.46. What is the ratio of the Rent(as % of GDP) in Congo (Republic) in 2007 to that in 2012?
Keep it short and to the point. 0.25. What is the ratio of the Rent(as % of GDP) in Kazakhstan in 2007 to that in 2012?
Your response must be concise. 1.55. What is the ratio of the Rent(as % of GDP) in Luxembourg in 2007 to that in 2012?
Offer a very short reply. 0.14. What is the ratio of the Rent(as % of GDP) of Mongolia in 2007 to that in 2012?
Your answer should be compact. 2.04. What is the ratio of the Rent(as % of GDP) in Congo (Republic) in 2007 to that in 2013?
Provide a succinct answer. 0.29. What is the ratio of the Rent(as % of GDP) in Kazakhstan in 2007 to that in 2013?
Ensure brevity in your answer.  1.88. What is the ratio of the Rent(as % of GDP) in Luxembourg in 2007 to that in 2013?
Your answer should be very brief. 0.21. What is the ratio of the Rent(as % of GDP) of Mongolia in 2007 to that in 2013?
Provide a succinct answer. 1.83. What is the ratio of the Rent(as % of GDP) in Congo (Republic) in 2008 to that in 2009?
Keep it short and to the point. 0.64. What is the ratio of the Rent(as % of GDP) of Kazakhstan in 2008 to that in 2009?
Your answer should be compact. 1.5. What is the ratio of the Rent(as % of GDP) of Luxembourg in 2008 to that in 2009?
Your answer should be very brief. 4. What is the ratio of the Rent(as % of GDP) in Mongolia in 2008 to that in 2009?
Your response must be concise. 1.2. What is the ratio of the Rent(as % of GDP) in Congo (Republic) in 2008 to that in 2010?
Give a very brief answer. 0.38. What is the ratio of the Rent(as % of GDP) of Kazakhstan in 2008 to that in 2010?
Provide a short and direct response. 1.01. What is the ratio of the Rent(as % of GDP) of Luxembourg in 2008 to that in 2010?
Make the answer very short. 4.2. What is the ratio of the Rent(as % of GDP) in Mongolia in 2008 to that in 2010?
Your answer should be very brief. 1.1. What is the ratio of the Rent(as % of GDP) of Congo (Republic) in 2008 to that in 2011?
Your answer should be compact. 0.34. What is the ratio of the Rent(as % of GDP) in Kazakhstan in 2008 to that in 2011?
Your answer should be very brief. 1.01. What is the ratio of the Rent(as % of GDP) of Luxembourg in 2008 to that in 2011?
Ensure brevity in your answer.  2.53. What is the ratio of the Rent(as % of GDP) of Mongolia in 2008 to that in 2011?
Offer a very short reply. 1.12. What is the ratio of the Rent(as % of GDP) of Congo (Republic) in 2008 to that in 2012?
Ensure brevity in your answer.  0.26. What is the ratio of the Rent(as % of GDP) of Kazakhstan in 2008 to that in 2012?
Provide a short and direct response. 1.25. What is the ratio of the Rent(as % of GDP) of Luxembourg in 2008 to that in 2012?
Offer a terse response. 2.38. What is the ratio of the Rent(as % of GDP) in Mongolia in 2008 to that in 2012?
Keep it short and to the point. 1.56. What is the ratio of the Rent(as % of GDP) in Congo (Republic) in 2008 to that in 2013?
Make the answer very short. 0.3. What is the ratio of the Rent(as % of GDP) of Kazakhstan in 2008 to that in 2013?
Keep it short and to the point. 1.51. What is the ratio of the Rent(as % of GDP) in Luxembourg in 2008 to that in 2013?
Your answer should be very brief. 3.63. What is the ratio of the Rent(as % of GDP) in Mongolia in 2008 to that in 2013?
Provide a short and direct response. 1.4. What is the ratio of the Rent(as % of GDP) in Congo (Republic) in 2009 to that in 2010?
Your response must be concise. 0.6. What is the ratio of the Rent(as % of GDP) of Kazakhstan in 2009 to that in 2010?
Provide a succinct answer. 0.68. What is the ratio of the Rent(as % of GDP) in Luxembourg in 2009 to that in 2010?
Make the answer very short. 1.05. What is the ratio of the Rent(as % of GDP) in Mongolia in 2009 to that in 2010?
Offer a very short reply. 0.91. What is the ratio of the Rent(as % of GDP) of Congo (Republic) in 2009 to that in 2011?
Offer a terse response. 0.53. What is the ratio of the Rent(as % of GDP) of Kazakhstan in 2009 to that in 2011?
Ensure brevity in your answer.  0.67. What is the ratio of the Rent(as % of GDP) of Luxembourg in 2009 to that in 2011?
Your answer should be compact. 0.63. What is the ratio of the Rent(as % of GDP) of Mongolia in 2009 to that in 2011?
Ensure brevity in your answer.  0.93. What is the ratio of the Rent(as % of GDP) of Congo (Republic) in 2009 to that in 2012?
Offer a very short reply. 0.4. What is the ratio of the Rent(as % of GDP) of Kazakhstan in 2009 to that in 2012?
Your answer should be very brief. 0.83. What is the ratio of the Rent(as % of GDP) in Luxembourg in 2009 to that in 2012?
Your answer should be very brief. 0.6. What is the ratio of the Rent(as % of GDP) of Mongolia in 2009 to that in 2012?
Offer a terse response. 1.3. What is the ratio of the Rent(as % of GDP) of Congo (Republic) in 2009 to that in 2013?
Offer a very short reply. 0.46. What is the ratio of the Rent(as % of GDP) in Kazakhstan in 2009 to that in 2013?
Offer a terse response. 1.01. What is the ratio of the Rent(as % of GDP) of Luxembourg in 2009 to that in 2013?
Ensure brevity in your answer.  0.91. What is the ratio of the Rent(as % of GDP) in Mongolia in 2009 to that in 2013?
Ensure brevity in your answer.  1.16. What is the ratio of the Rent(as % of GDP) in Congo (Republic) in 2010 to that in 2011?
Your response must be concise. 0.88. What is the ratio of the Rent(as % of GDP) in Kazakhstan in 2010 to that in 2011?
Provide a succinct answer. 1. What is the ratio of the Rent(as % of GDP) of Luxembourg in 2010 to that in 2011?
Keep it short and to the point. 0.6. What is the ratio of the Rent(as % of GDP) of Mongolia in 2010 to that in 2011?
Your response must be concise. 1.02. What is the ratio of the Rent(as % of GDP) of Congo (Republic) in 2010 to that in 2012?
Keep it short and to the point. 0.67. What is the ratio of the Rent(as % of GDP) in Kazakhstan in 2010 to that in 2012?
Offer a terse response. 1.23. What is the ratio of the Rent(as % of GDP) of Luxembourg in 2010 to that in 2012?
Ensure brevity in your answer.  0.57. What is the ratio of the Rent(as % of GDP) of Mongolia in 2010 to that in 2012?
Ensure brevity in your answer.  1.42. What is the ratio of the Rent(as % of GDP) in Congo (Republic) in 2010 to that in 2013?
Your answer should be compact. 0.78. What is the ratio of the Rent(as % of GDP) in Kazakhstan in 2010 to that in 2013?
Give a very brief answer. 1.49. What is the ratio of the Rent(as % of GDP) of Luxembourg in 2010 to that in 2013?
Offer a terse response. 0.86. What is the ratio of the Rent(as % of GDP) in Mongolia in 2010 to that in 2013?
Keep it short and to the point. 1.28. What is the ratio of the Rent(as % of GDP) in Congo (Republic) in 2011 to that in 2012?
Your answer should be compact. 0.77. What is the ratio of the Rent(as % of GDP) in Kazakhstan in 2011 to that in 2012?
Your answer should be very brief. 1.23. What is the ratio of the Rent(as % of GDP) of Luxembourg in 2011 to that in 2012?
Provide a succinct answer. 0.94. What is the ratio of the Rent(as % of GDP) in Mongolia in 2011 to that in 2012?
Offer a very short reply. 1.4. What is the ratio of the Rent(as % of GDP) of Congo (Republic) in 2011 to that in 2013?
Ensure brevity in your answer.  0.88. What is the ratio of the Rent(as % of GDP) of Kazakhstan in 2011 to that in 2013?
Provide a short and direct response. 1.49. What is the ratio of the Rent(as % of GDP) of Luxembourg in 2011 to that in 2013?
Offer a very short reply. 1.44. What is the ratio of the Rent(as % of GDP) in Mongolia in 2011 to that in 2013?
Offer a terse response. 1.25. What is the ratio of the Rent(as % of GDP) in Congo (Republic) in 2012 to that in 2013?
Provide a succinct answer. 1.15. What is the ratio of the Rent(as % of GDP) of Kazakhstan in 2012 to that in 2013?
Offer a terse response. 1.21. What is the ratio of the Rent(as % of GDP) in Luxembourg in 2012 to that in 2013?
Provide a succinct answer. 1.53. What is the ratio of the Rent(as % of GDP) of Mongolia in 2012 to that in 2013?
Your answer should be compact. 0.9. What is the difference between the highest and the second highest Rent(as % of GDP) in Congo (Republic)?
Your answer should be very brief. 0.01. What is the difference between the highest and the second highest Rent(as % of GDP) in Kazakhstan?
Provide a succinct answer. 1.11. What is the difference between the highest and the second highest Rent(as % of GDP) of Luxembourg?
Offer a very short reply. 0.14. What is the difference between the highest and the second highest Rent(as % of GDP) in Mongolia?
Provide a short and direct response. 6.14. What is the difference between the highest and the lowest Rent(as % of GDP) in Congo (Republic)?
Offer a very short reply. 0.04. What is the difference between the highest and the lowest Rent(as % of GDP) of Kazakhstan?
Keep it short and to the point. 2.65. What is the difference between the highest and the lowest Rent(as % of GDP) of Luxembourg?
Give a very brief answer. 0.23. What is the difference between the highest and the lowest Rent(as % of GDP) in Mongolia?
Your answer should be compact. 13.38. 